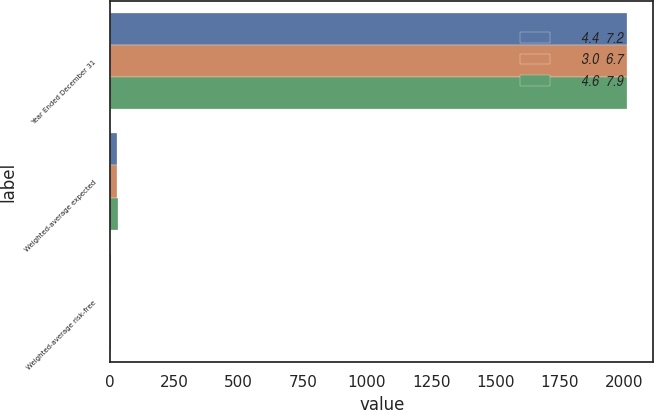Convert chart to OTSL. <chart><loc_0><loc_0><loc_500><loc_500><stacked_bar_chart><ecel><fcel>Year Ended December 31<fcel>Weighted-average expected<fcel>Weighted-average risk-free<nl><fcel>4.4  7.2<fcel>2014<fcel>28<fcel>2.4<nl><fcel>3.0  6.7<fcel>2013<fcel>28<fcel>2.5<nl><fcel>4.6  7.9<fcel>2012<fcel>31<fcel>1.8<nl></chart> 